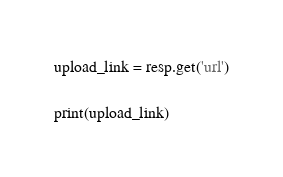Convert code to text. <code><loc_0><loc_0><loc_500><loc_500><_Python_>upload_link = resp.get('url')

print(upload_link)
</code> 